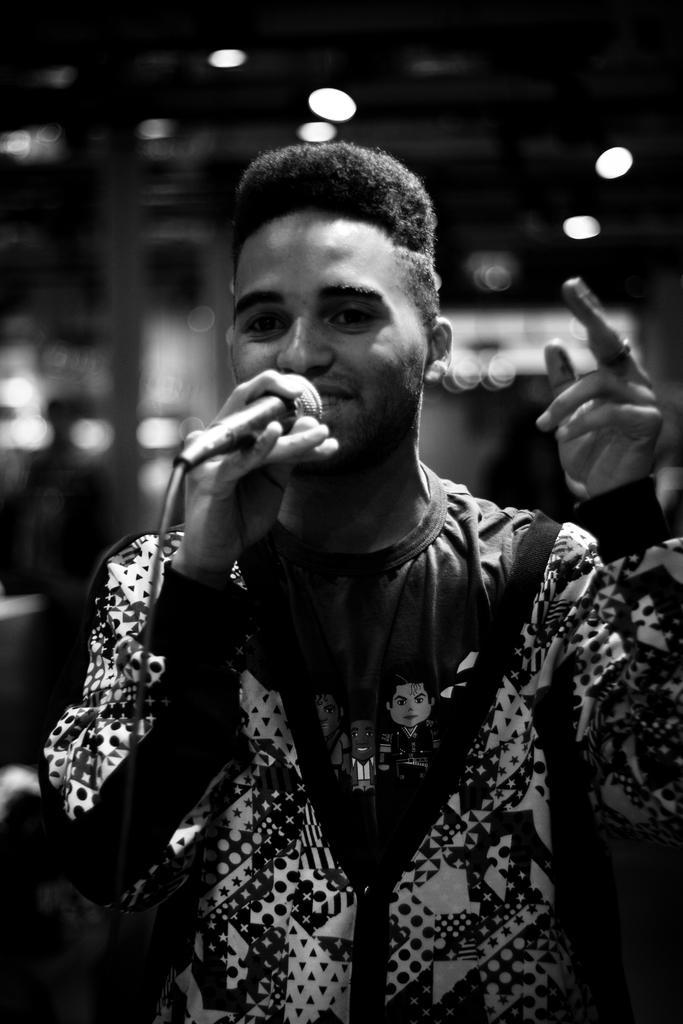How would you summarize this image in a sentence or two? This is a black and white image. There is a person standing in the front. He is holding a mic. There are lights on the top. 